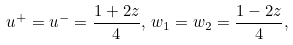<formula> <loc_0><loc_0><loc_500><loc_500>u ^ { + } = u ^ { - } = \frac { 1 + 2 z } { 4 } , \, w _ { 1 } = w _ { 2 } = \frac { 1 - 2 z } { 4 } ,</formula> 